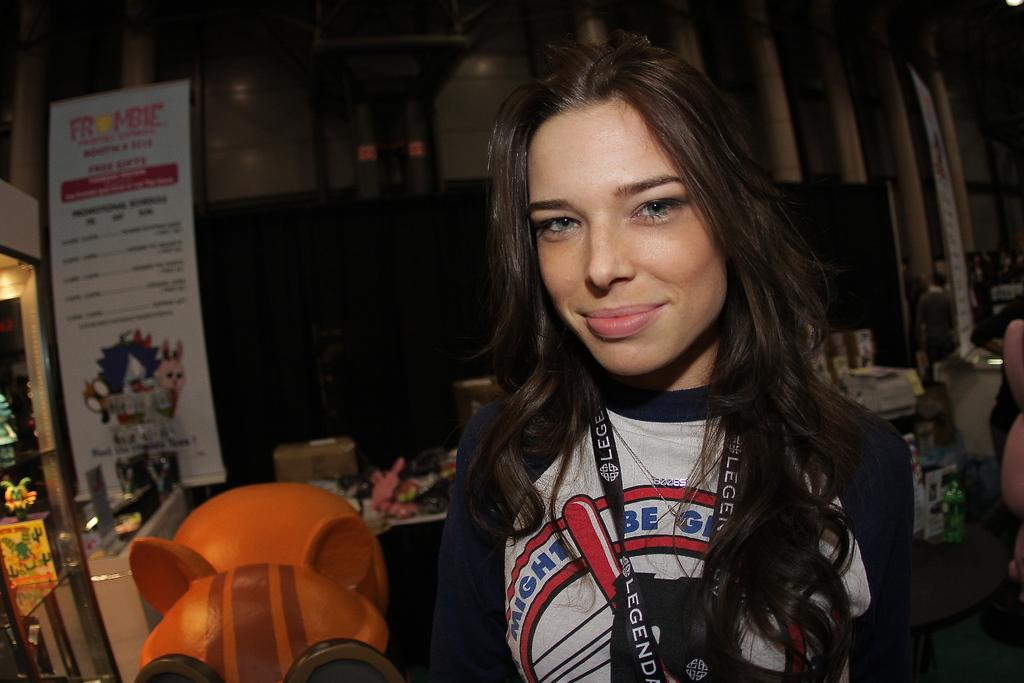<image>
Provide a brief description of the given image. A woman is wearing a lanyard that has the word "legend" on it. 